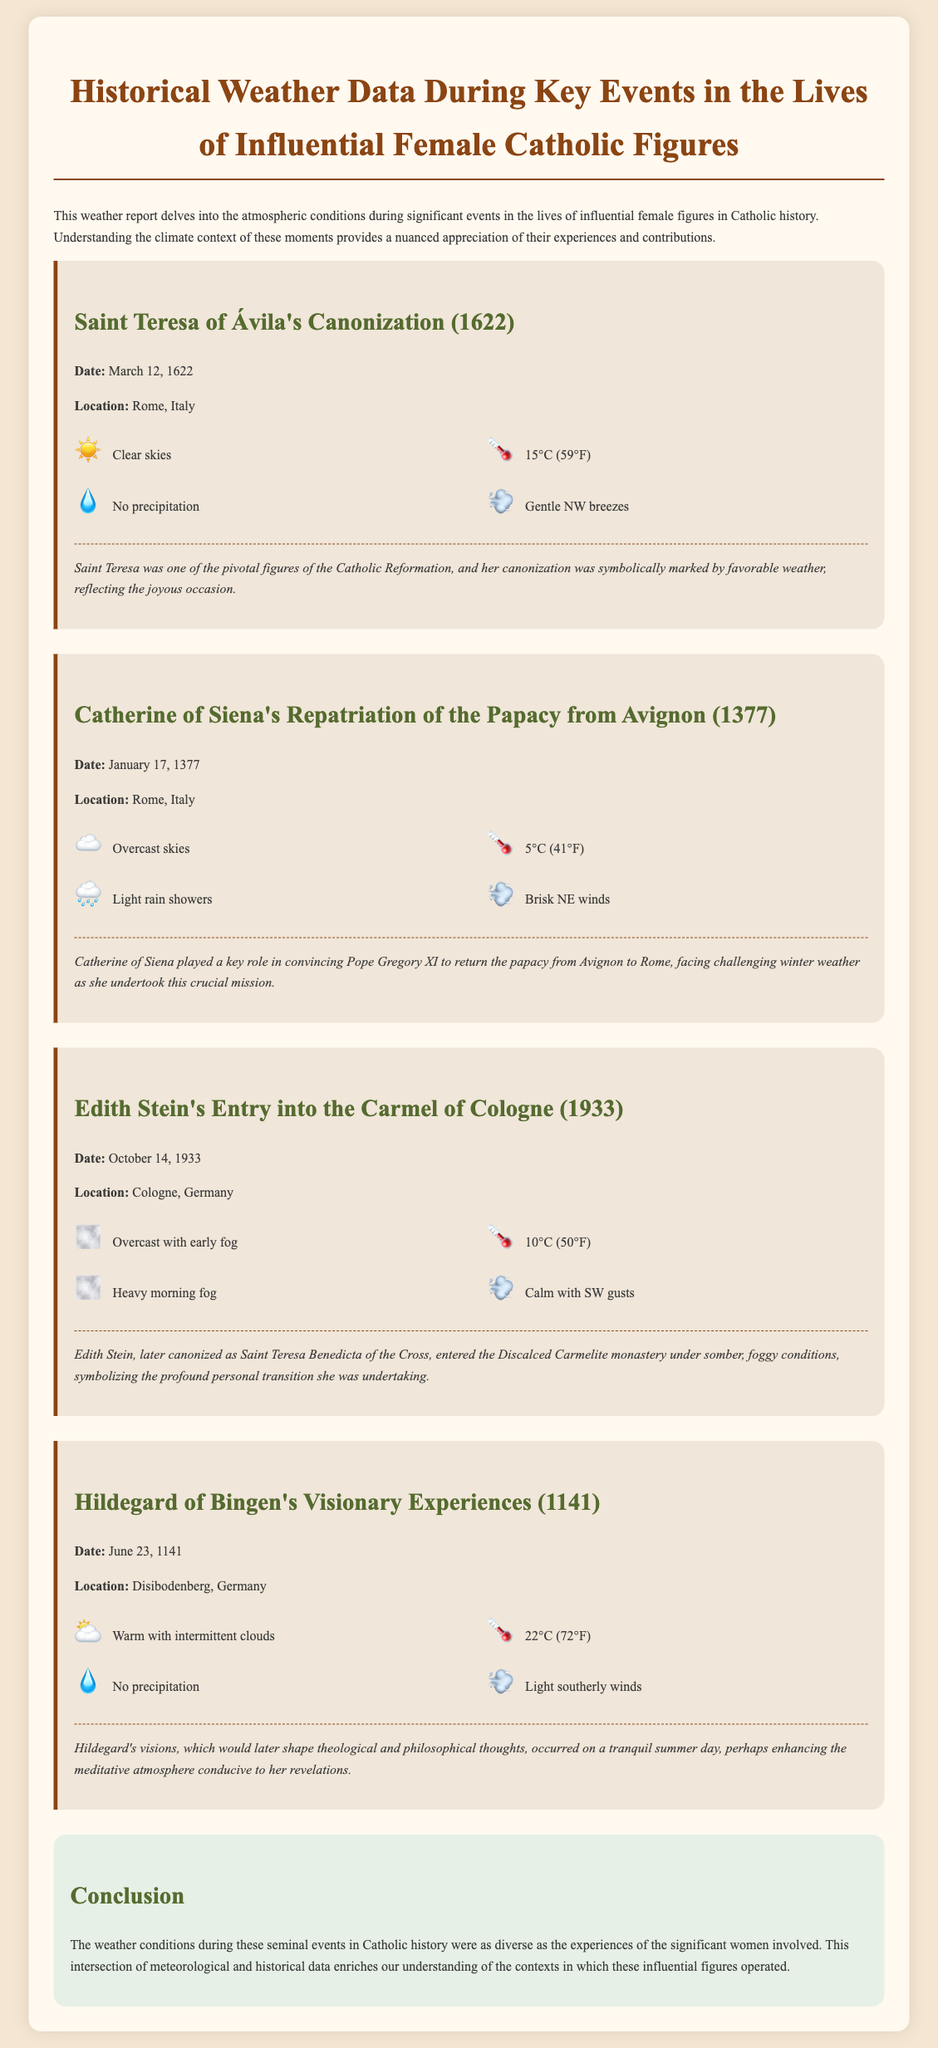What event took place on March 12, 1622? The event is the canonization of Saint Teresa of Ávila, which is mentioned in the document.
Answer: canonization of Saint Teresa of Ávila What was the weather on January 17, 1377? The document describes the weather on this date as overcast skies, 5°C, light rain showers, and brisk NE winds.
Answer: Overcast skies What was the temperature during Edith Stein's entry into the Carmel of Cologne? The document states the temperature as 10°C on October 14, 1933.
Answer: 10°C What significant role did Catherine of Siena play in 1377? The document notes that she convinced Pope Gregory XI to return the papacy from Avignon to Rome.
Answer: convinced Pope Gregory XI What was the overall weather condition during Hildegard of Bingen's visionary experiences? The weather on June 23, 1141 is described as warm with intermittent clouds.
Answer: warm with intermittent clouds Which figure's canonization was marked by clear skies? The document indicates that Saint Teresa of Ávila's canonization was symbolically marked by favorable weather.
Answer: Saint Teresa of Ávila What type of document is this? The structure and content of the document categorize it as a weather report detailing historical data.
Answer: weather report What is a notable feature of the weather on Edith Stein's entrance? The weather is described as overcast with heavy morning fog, highlighting a somber atmosphere.
Answer: heavy morning fog What does the conclusion highlight about the weather conditions? The conclusion reflects on the diversity of weather conditions during the events of influential women in Catholic history.
Answer: diversity of weather conditions 